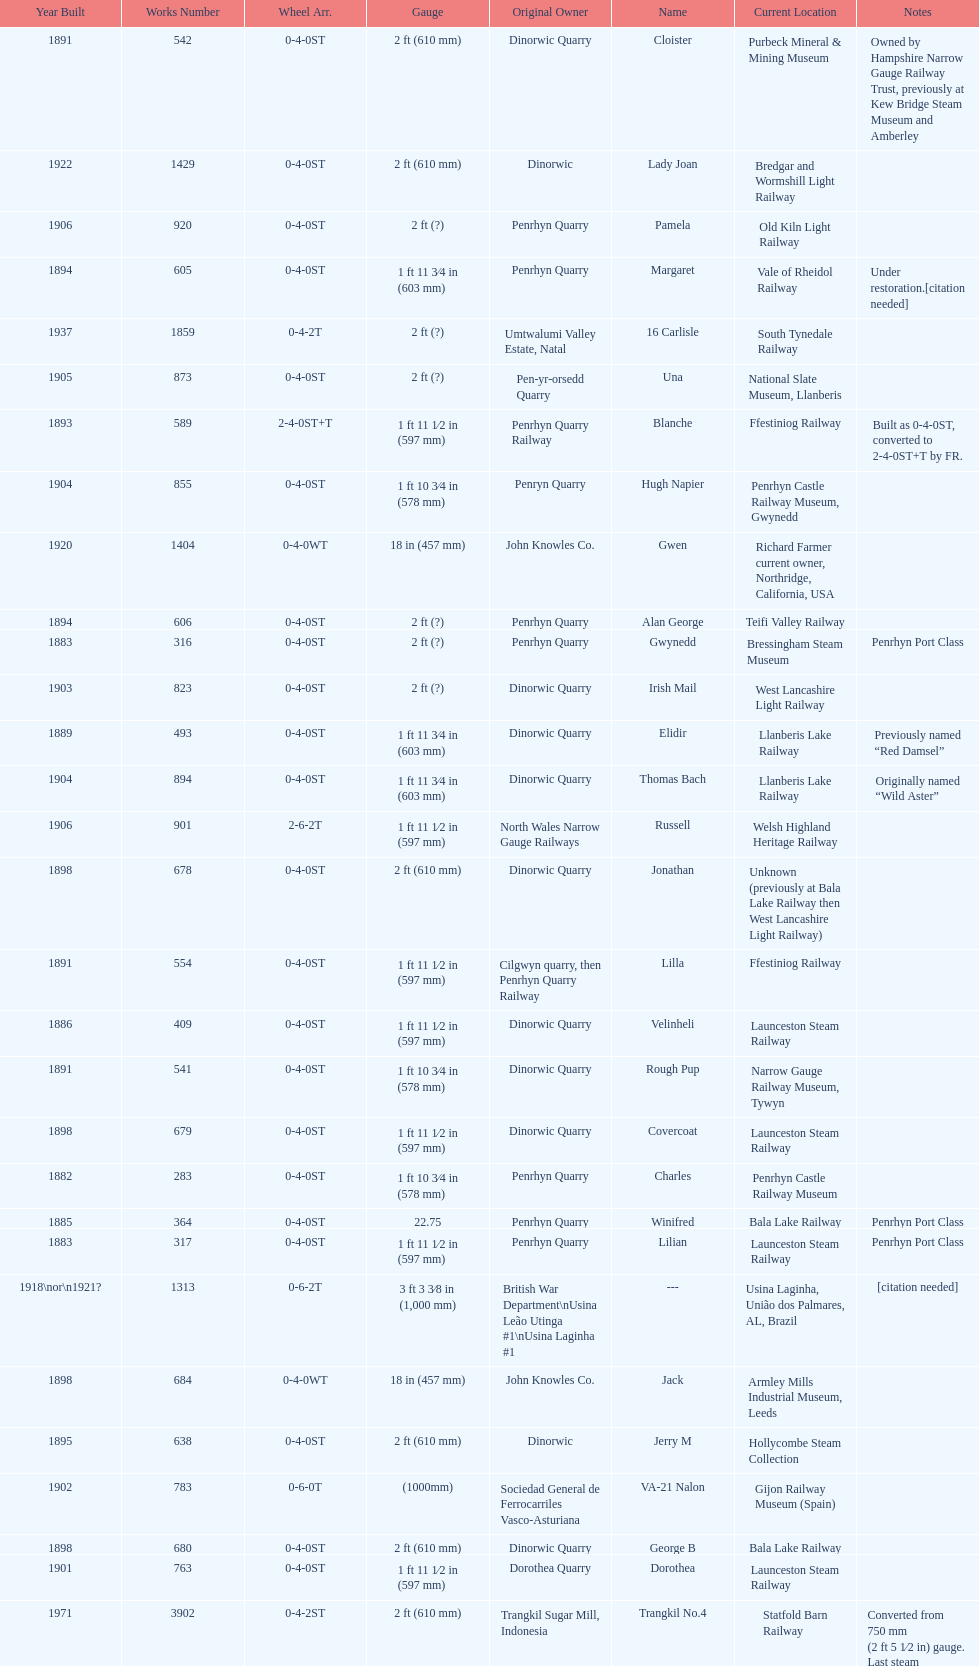After 1940, how many steam locomotives were built? 2. 